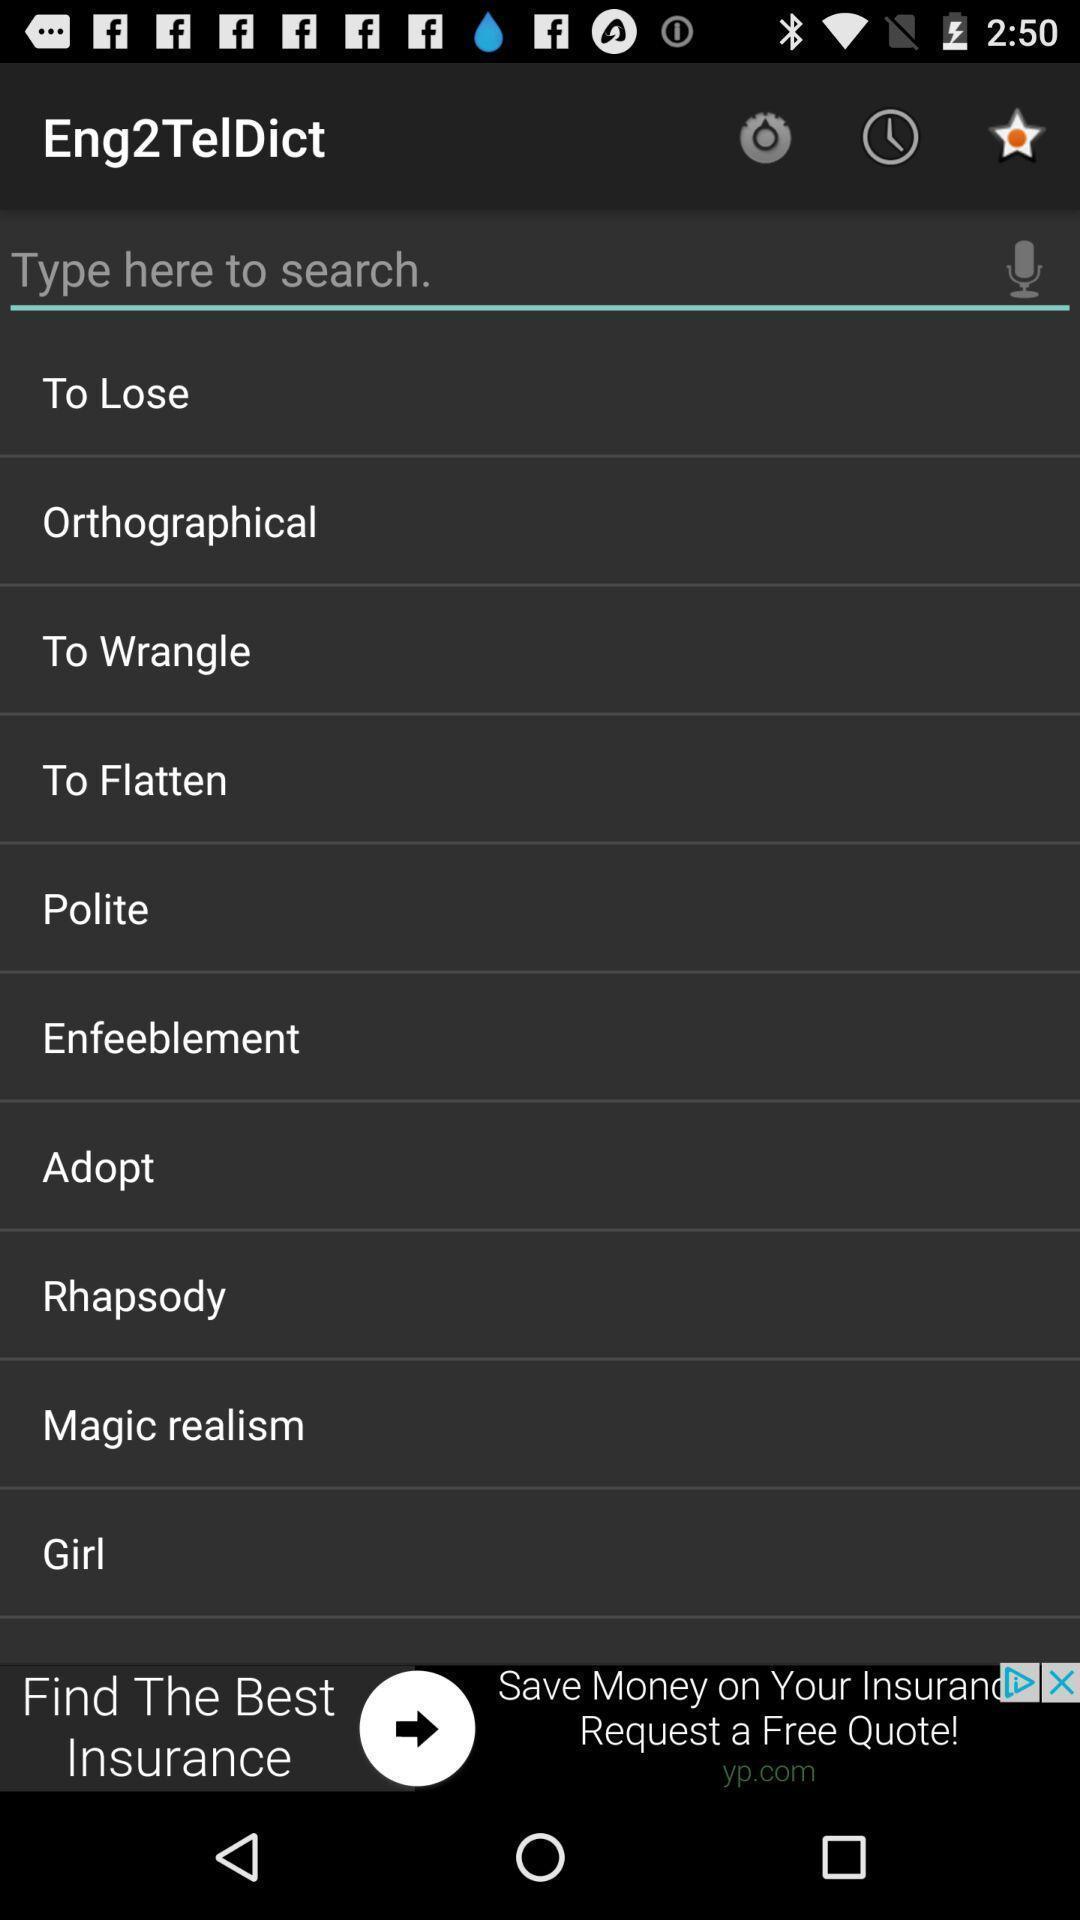Summarize the main components in this picture. Search bar in a dictionary app. 